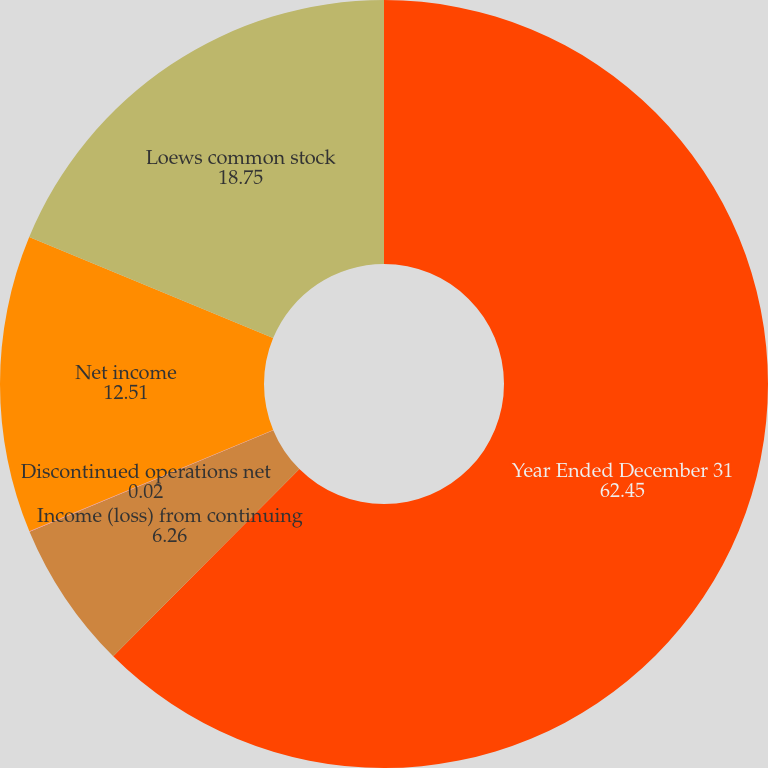<chart> <loc_0><loc_0><loc_500><loc_500><pie_chart><fcel>Year Ended December 31<fcel>Income (loss) from continuing<fcel>Discontinued operations net<fcel>Net income<fcel>Loews common stock<nl><fcel>62.45%<fcel>6.26%<fcel>0.02%<fcel>12.51%<fcel>18.75%<nl></chart> 